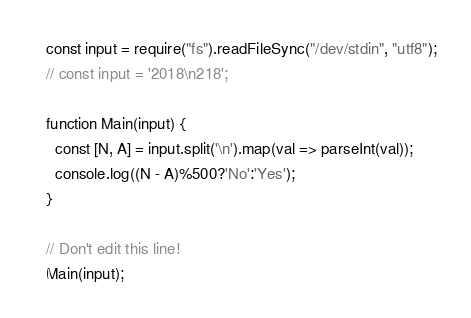<code> <loc_0><loc_0><loc_500><loc_500><_JavaScript_>const input = require("fs").readFileSync("/dev/stdin", "utf8");
// const input = '2018\n218';

function Main(input) {
  const [N, A] = input.split('\n').map(val => parseInt(val));
  console.log((N - A)%500?'No':'Yes');
}

// Don't edit this line!
Main(input);</code> 